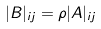Convert formula to latex. <formula><loc_0><loc_0><loc_500><loc_500>| B | _ { i j } = \rho | A | _ { i j }</formula> 